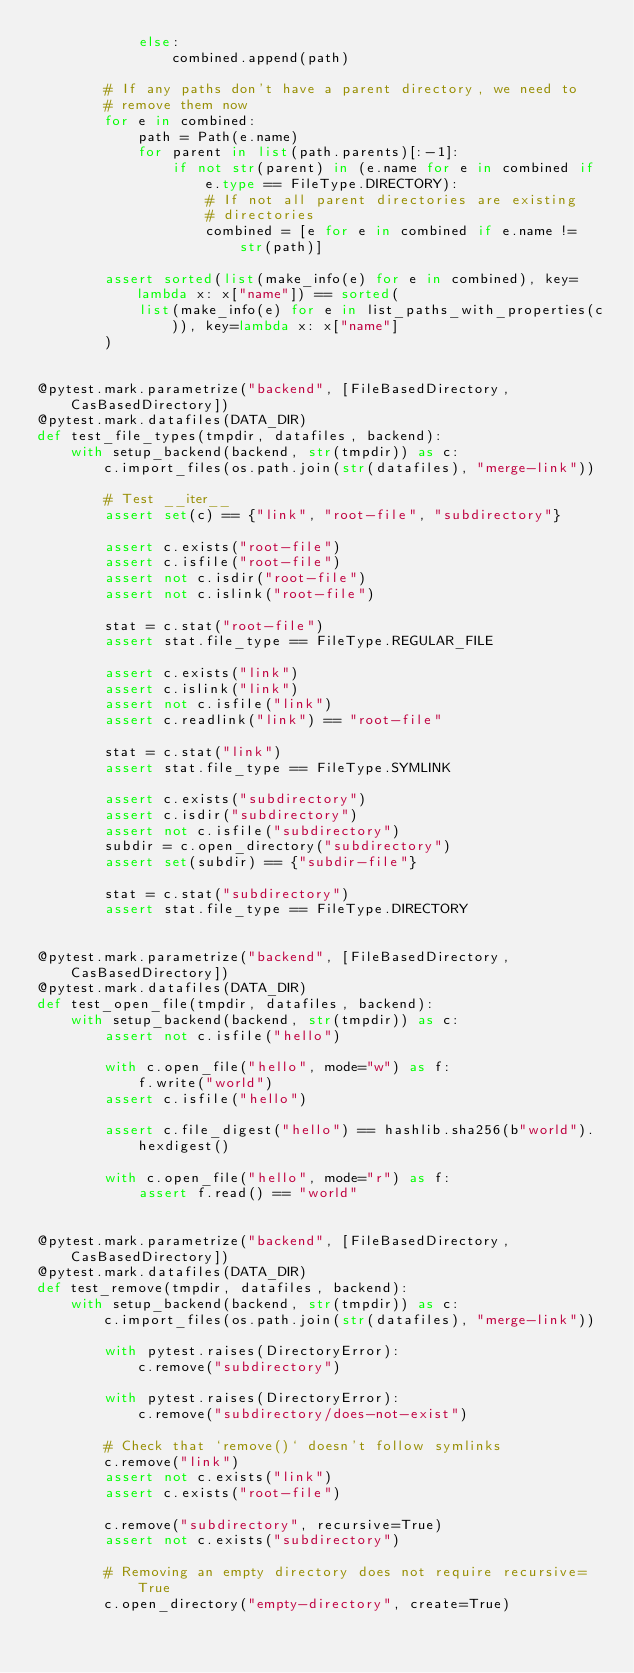Convert code to text. <code><loc_0><loc_0><loc_500><loc_500><_Python_>            else:
                combined.append(path)

        # If any paths don't have a parent directory, we need to
        # remove them now
        for e in combined:
            path = Path(e.name)
            for parent in list(path.parents)[:-1]:
                if not str(parent) in (e.name for e in combined if e.type == FileType.DIRECTORY):
                    # If not all parent directories are existing
                    # directories
                    combined = [e for e in combined if e.name != str(path)]

        assert sorted(list(make_info(e) for e in combined), key=lambda x: x["name"]) == sorted(
            list(make_info(e) for e in list_paths_with_properties(c)), key=lambda x: x["name"]
        )


@pytest.mark.parametrize("backend", [FileBasedDirectory, CasBasedDirectory])
@pytest.mark.datafiles(DATA_DIR)
def test_file_types(tmpdir, datafiles, backend):
    with setup_backend(backend, str(tmpdir)) as c:
        c.import_files(os.path.join(str(datafiles), "merge-link"))

        # Test __iter__
        assert set(c) == {"link", "root-file", "subdirectory"}

        assert c.exists("root-file")
        assert c.isfile("root-file")
        assert not c.isdir("root-file")
        assert not c.islink("root-file")

        stat = c.stat("root-file")
        assert stat.file_type == FileType.REGULAR_FILE

        assert c.exists("link")
        assert c.islink("link")
        assert not c.isfile("link")
        assert c.readlink("link") == "root-file"

        stat = c.stat("link")
        assert stat.file_type == FileType.SYMLINK

        assert c.exists("subdirectory")
        assert c.isdir("subdirectory")
        assert not c.isfile("subdirectory")
        subdir = c.open_directory("subdirectory")
        assert set(subdir) == {"subdir-file"}

        stat = c.stat("subdirectory")
        assert stat.file_type == FileType.DIRECTORY


@pytest.mark.parametrize("backend", [FileBasedDirectory, CasBasedDirectory])
@pytest.mark.datafiles(DATA_DIR)
def test_open_file(tmpdir, datafiles, backend):
    with setup_backend(backend, str(tmpdir)) as c:
        assert not c.isfile("hello")

        with c.open_file("hello", mode="w") as f:
            f.write("world")
        assert c.isfile("hello")

        assert c.file_digest("hello") == hashlib.sha256(b"world").hexdigest()

        with c.open_file("hello", mode="r") as f:
            assert f.read() == "world"


@pytest.mark.parametrize("backend", [FileBasedDirectory, CasBasedDirectory])
@pytest.mark.datafiles(DATA_DIR)
def test_remove(tmpdir, datafiles, backend):
    with setup_backend(backend, str(tmpdir)) as c:
        c.import_files(os.path.join(str(datafiles), "merge-link"))

        with pytest.raises(DirectoryError):
            c.remove("subdirectory")

        with pytest.raises(DirectoryError):
            c.remove("subdirectory/does-not-exist")

        # Check that `remove()` doesn't follow symlinks
        c.remove("link")
        assert not c.exists("link")
        assert c.exists("root-file")

        c.remove("subdirectory", recursive=True)
        assert not c.exists("subdirectory")

        # Removing an empty directory does not require recursive=True
        c.open_directory("empty-directory", create=True)</code> 